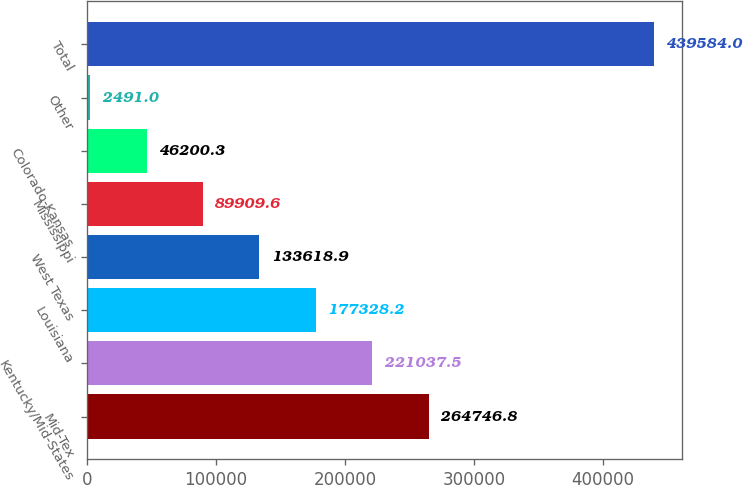Convert chart to OTSL. <chart><loc_0><loc_0><loc_500><loc_500><bar_chart><fcel>Mid-Tex<fcel>Kentucky/Mid-States<fcel>Louisiana<fcel>West Texas<fcel>Mississippi<fcel>Colorado-Kansas<fcel>Other<fcel>Total<nl><fcel>264747<fcel>221038<fcel>177328<fcel>133619<fcel>89909.6<fcel>46200.3<fcel>2491<fcel>439584<nl></chart> 